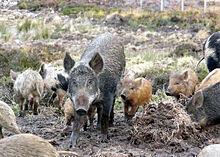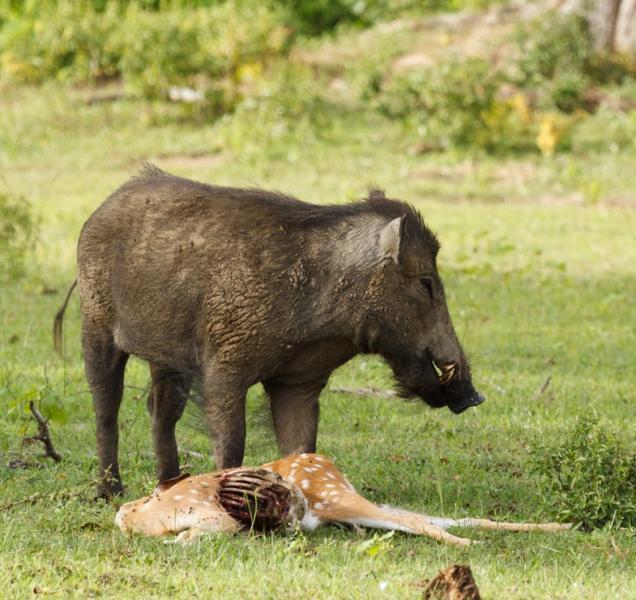The first image is the image on the left, the second image is the image on the right. Examine the images to the left and right. Is the description "The right image contains exactly two boars." accurate? Answer yes or no. No. 